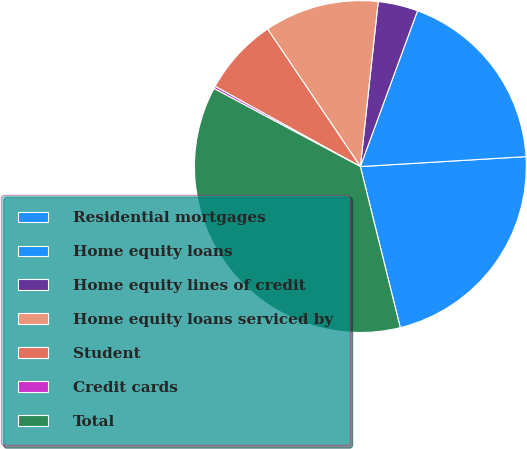Convert chart. <chart><loc_0><loc_0><loc_500><loc_500><pie_chart><fcel>Residential mortgages<fcel>Home equity loans<fcel>Home equity lines of credit<fcel>Home equity loans serviced by<fcel>Student<fcel>Credit cards<fcel>Total<nl><fcel>22.09%<fcel>18.45%<fcel>3.88%<fcel>11.16%<fcel>7.52%<fcel>0.24%<fcel>36.66%<nl></chart> 